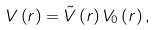<formula> <loc_0><loc_0><loc_500><loc_500>V \left ( r \right ) = \tilde { V } \left ( r \right ) V _ { 0 } \left ( r \right ) ,</formula> 